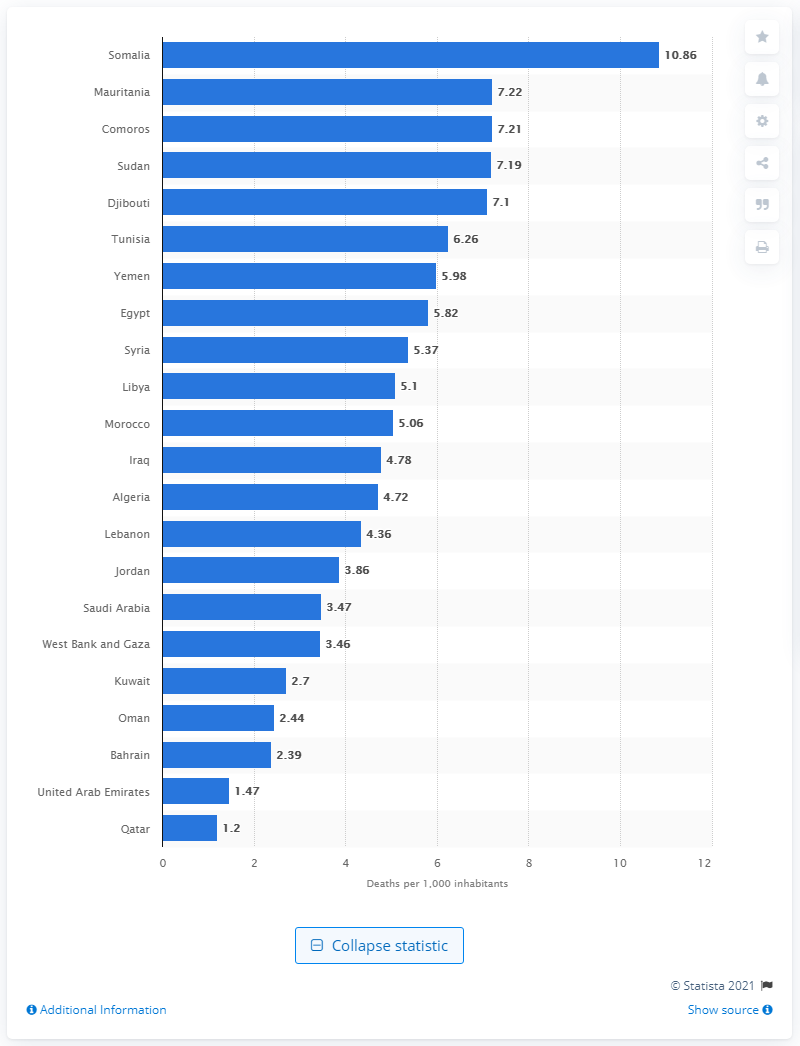Specify some key components in this picture. In 2018, the death rate in Somalia was 10.86 deaths per 1,000 inhabitants. 